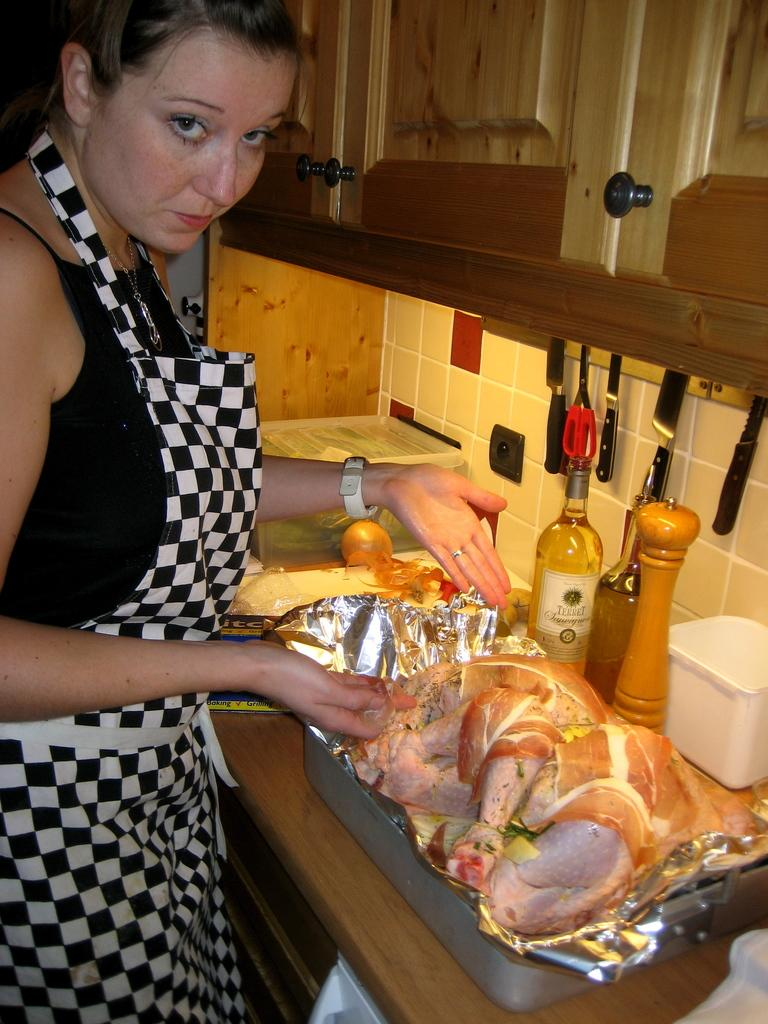Who is present on the left side of the image? There is a woman on the left side of the image. What type of containers can be seen in the image? There are bottles in the image. What type of food is visible in the image? There is meat in the image. What type of storage units are present in the image? There are boxes and cupboards in the image. What type of kitchenware is visible in the image? There are vessels in the image. What type of utensils are visible in the image? There are knives in the image. What type of flooring is present in the image? There are tiles in the image. What type of structure is present in the image? There is a wall in the image. Can you see any friends or sheep in the image? No, there are no friends or sheep present in the image. 